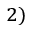Convert formula to latex. <formula><loc_0><loc_0><loc_500><loc_500>^ { 2 ) }</formula> 